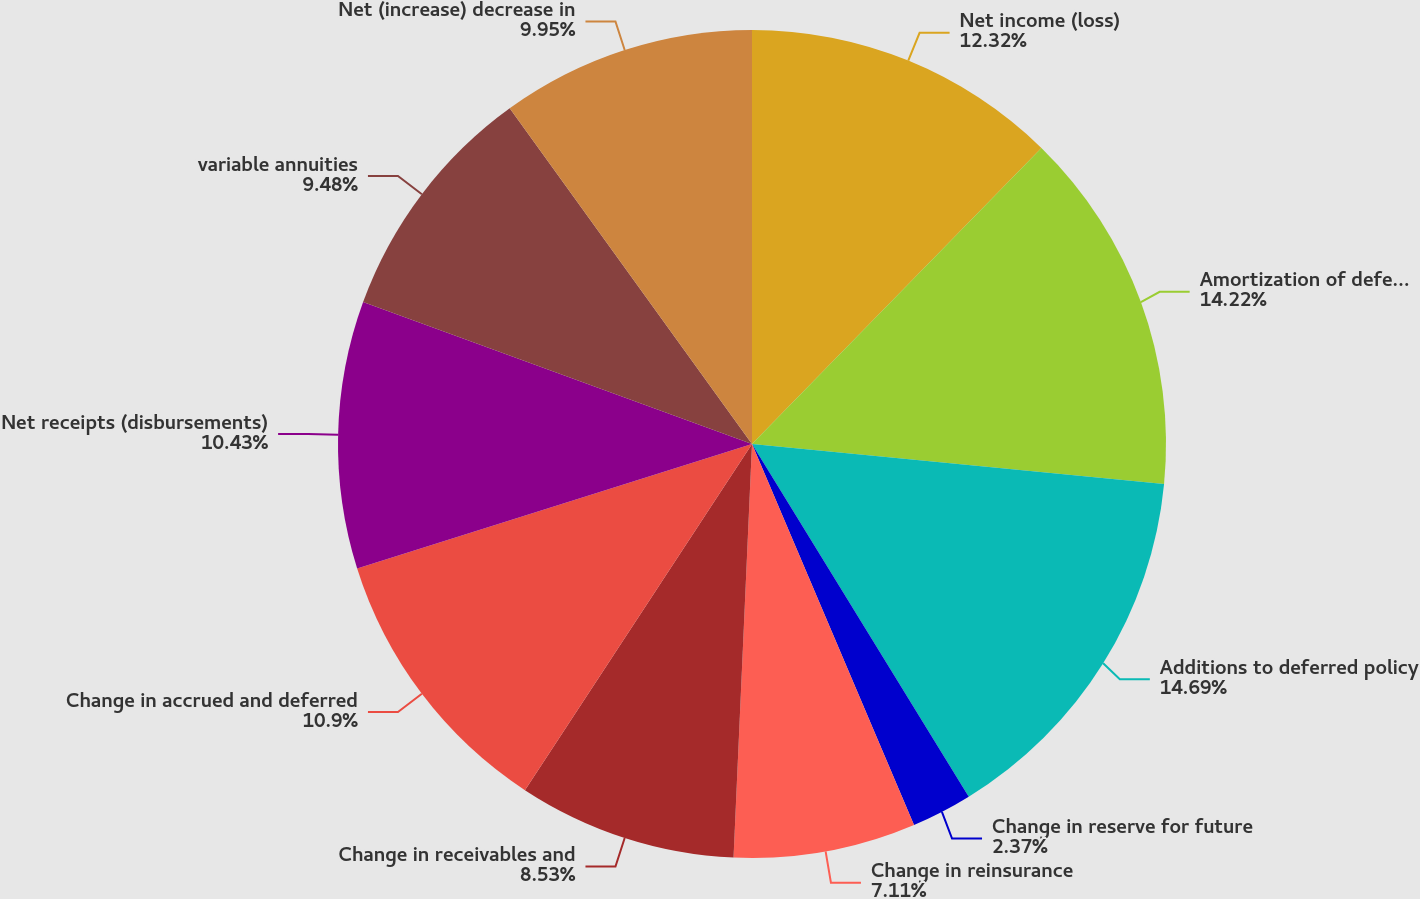<chart> <loc_0><loc_0><loc_500><loc_500><pie_chart><fcel>Net income (loss)<fcel>Amortization of deferred<fcel>Additions to deferred policy<fcel>Change in reserve for future<fcel>Change in reinsurance<fcel>Change in receivables and<fcel>Change in accrued and deferred<fcel>Net receipts (disbursements)<fcel>variable annuities<fcel>Net (increase) decrease in<nl><fcel>12.32%<fcel>14.22%<fcel>14.69%<fcel>2.37%<fcel>7.11%<fcel>8.53%<fcel>10.9%<fcel>10.43%<fcel>9.48%<fcel>9.95%<nl></chart> 